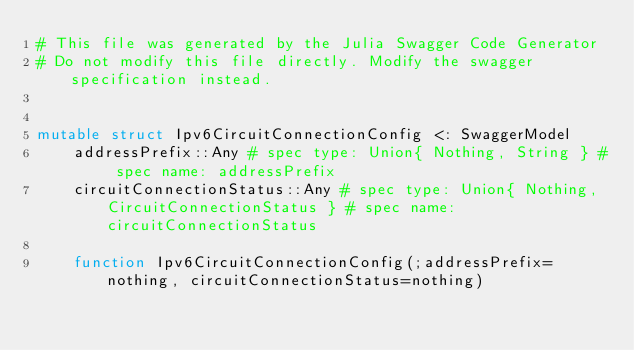<code> <loc_0><loc_0><loc_500><loc_500><_Julia_># This file was generated by the Julia Swagger Code Generator
# Do not modify this file directly. Modify the swagger specification instead.


mutable struct Ipv6CircuitConnectionConfig <: SwaggerModel
    addressPrefix::Any # spec type: Union{ Nothing, String } # spec name: addressPrefix
    circuitConnectionStatus::Any # spec type: Union{ Nothing, CircuitConnectionStatus } # spec name: circuitConnectionStatus

    function Ipv6CircuitConnectionConfig(;addressPrefix=nothing, circuitConnectionStatus=nothing)</code> 